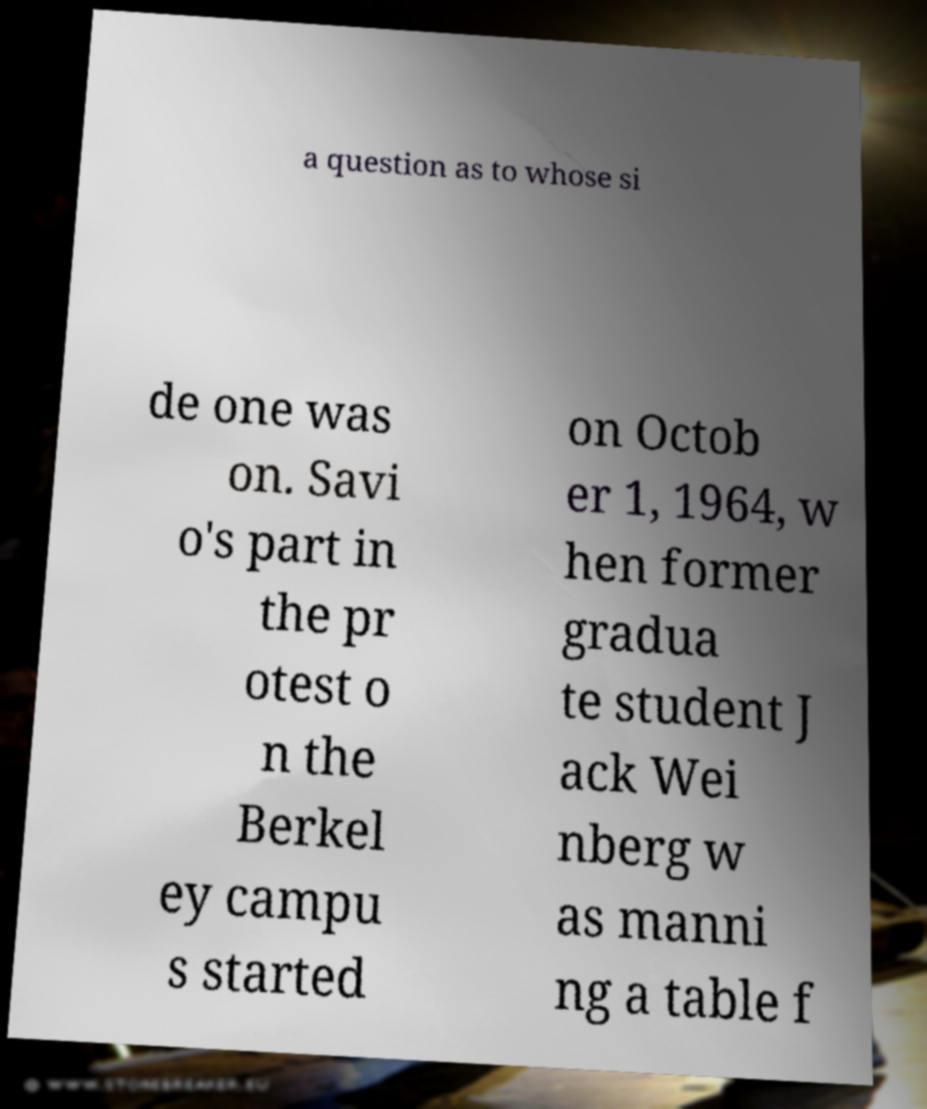Could you extract and type out the text from this image? a question as to whose si de one was on. Savi o's part in the pr otest o n the Berkel ey campu s started on Octob er 1, 1964, w hen former gradua te student J ack Wei nberg w as manni ng a table f 